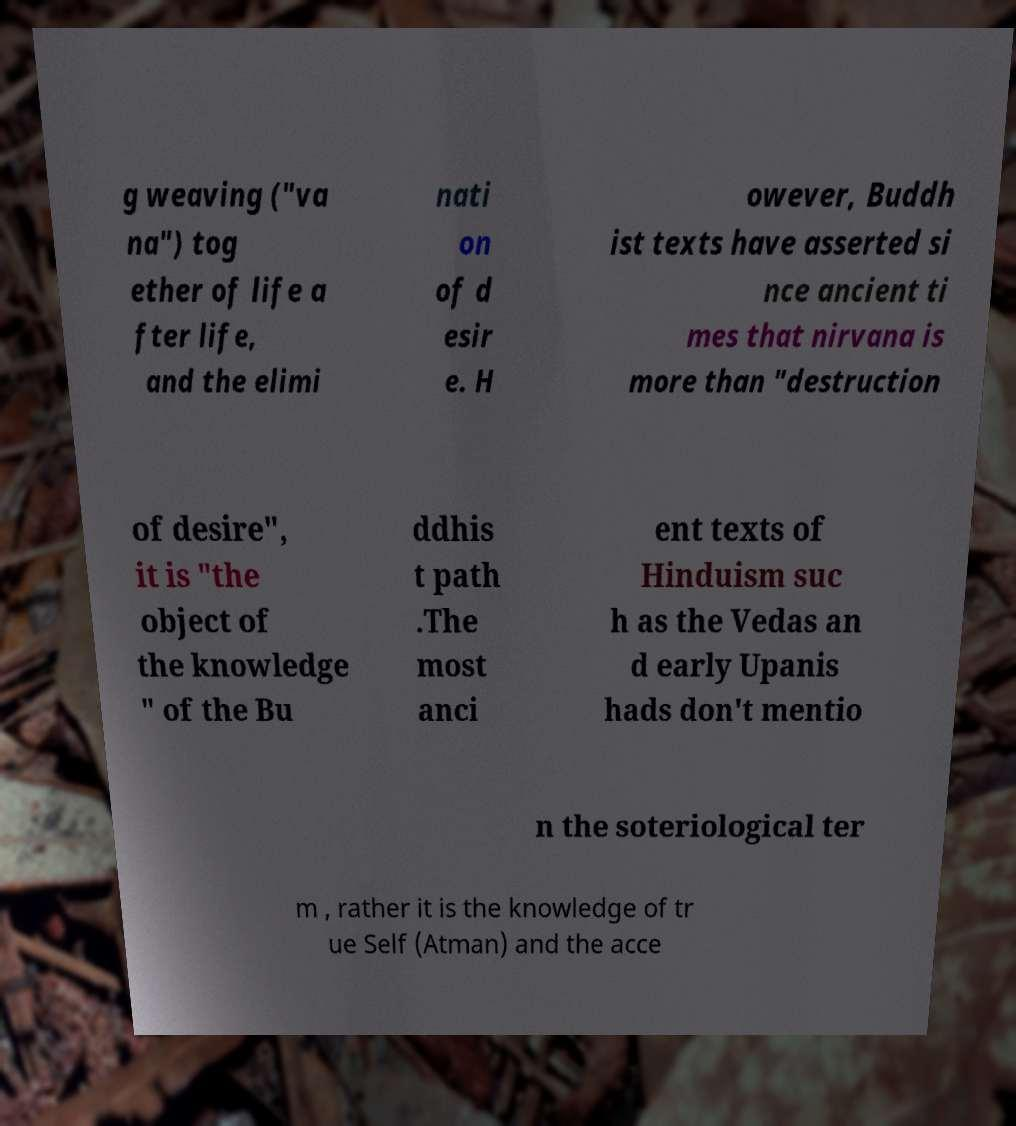Please identify and transcribe the text found in this image. g weaving ("va na") tog ether of life a fter life, and the elimi nati on of d esir e. H owever, Buddh ist texts have asserted si nce ancient ti mes that nirvana is more than "destruction of desire", it is "the object of the knowledge " of the Bu ddhis t path .The most anci ent texts of Hinduism suc h as the Vedas an d early Upanis hads don't mentio n the soteriological ter m , rather it is the knowledge of tr ue Self (Atman) and the acce 